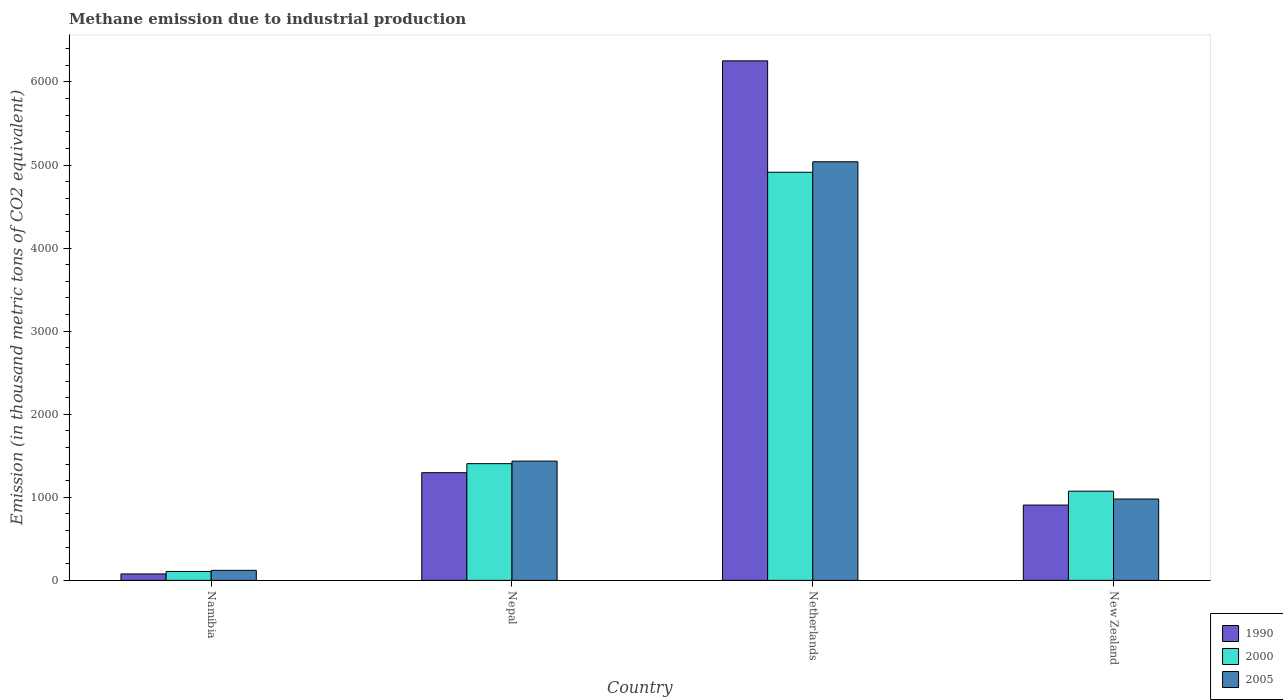How many different coloured bars are there?
Ensure brevity in your answer.  3. Are the number of bars per tick equal to the number of legend labels?
Make the answer very short. Yes. How many bars are there on the 1st tick from the left?
Your answer should be compact. 3. What is the label of the 1st group of bars from the left?
Offer a very short reply. Namibia. In how many cases, is the number of bars for a given country not equal to the number of legend labels?
Offer a very short reply. 0. What is the amount of methane emitted in 2000 in Namibia?
Give a very brief answer. 107.4. Across all countries, what is the maximum amount of methane emitted in 2000?
Offer a very short reply. 4913.4. Across all countries, what is the minimum amount of methane emitted in 2005?
Provide a short and direct response. 121. In which country was the amount of methane emitted in 2000 minimum?
Keep it short and to the point. Namibia. What is the total amount of methane emitted in 2000 in the graph?
Ensure brevity in your answer.  7499.9. What is the difference between the amount of methane emitted in 1990 in Namibia and that in Netherlands?
Provide a short and direct response. -6176.8. What is the difference between the amount of methane emitted in 2000 in New Zealand and the amount of methane emitted in 2005 in Netherlands?
Provide a short and direct response. -3965.5. What is the average amount of methane emitted in 2000 per country?
Your answer should be compact. 1874.97. What is the difference between the amount of methane emitted of/in 2000 and amount of methane emitted of/in 2005 in New Zealand?
Your response must be concise. 94.6. In how many countries, is the amount of methane emitted in 2005 greater than 6200 thousand metric tons?
Give a very brief answer. 0. What is the ratio of the amount of methane emitted in 2000 in Namibia to that in Nepal?
Your answer should be very brief. 0.08. Is the difference between the amount of methane emitted in 2000 in Namibia and Netherlands greater than the difference between the amount of methane emitted in 2005 in Namibia and Netherlands?
Provide a succinct answer. Yes. What is the difference between the highest and the second highest amount of methane emitted in 2005?
Provide a short and direct response. 456.4. What is the difference between the highest and the lowest amount of methane emitted in 2005?
Provide a succinct answer. 4918.5. In how many countries, is the amount of methane emitted in 1990 greater than the average amount of methane emitted in 1990 taken over all countries?
Your response must be concise. 1. Is the sum of the amount of methane emitted in 2005 in Nepal and Netherlands greater than the maximum amount of methane emitted in 1990 across all countries?
Your answer should be very brief. Yes. What does the 3rd bar from the left in New Zealand represents?
Offer a terse response. 2005. What does the 1st bar from the right in New Zealand represents?
Provide a succinct answer. 2005. Are all the bars in the graph horizontal?
Keep it short and to the point. No. How many countries are there in the graph?
Your answer should be compact. 4. Are the values on the major ticks of Y-axis written in scientific E-notation?
Offer a very short reply. No. Where does the legend appear in the graph?
Provide a short and direct response. Bottom right. How are the legend labels stacked?
Offer a terse response. Vertical. What is the title of the graph?
Make the answer very short. Methane emission due to industrial production. What is the label or title of the X-axis?
Your answer should be compact. Country. What is the label or title of the Y-axis?
Provide a short and direct response. Emission (in thousand metric tons of CO2 equivalent). What is the Emission (in thousand metric tons of CO2 equivalent) in 1990 in Namibia?
Provide a succinct answer. 77.6. What is the Emission (in thousand metric tons of CO2 equivalent) of 2000 in Namibia?
Your answer should be compact. 107.4. What is the Emission (in thousand metric tons of CO2 equivalent) in 2005 in Namibia?
Your response must be concise. 121. What is the Emission (in thousand metric tons of CO2 equivalent) in 1990 in Nepal?
Provide a succinct answer. 1296.6. What is the Emission (in thousand metric tons of CO2 equivalent) in 2000 in Nepal?
Ensure brevity in your answer.  1405.1. What is the Emission (in thousand metric tons of CO2 equivalent) in 2005 in Nepal?
Offer a terse response. 1435.8. What is the Emission (in thousand metric tons of CO2 equivalent) in 1990 in Netherlands?
Offer a very short reply. 6254.4. What is the Emission (in thousand metric tons of CO2 equivalent) in 2000 in Netherlands?
Make the answer very short. 4913.4. What is the Emission (in thousand metric tons of CO2 equivalent) in 2005 in Netherlands?
Provide a short and direct response. 5039.5. What is the Emission (in thousand metric tons of CO2 equivalent) in 1990 in New Zealand?
Your answer should be very brief. 906.8. What is the Emission (in thousand metric tons of CO2 equivalent) in 2000 in New Zealand?
Keep it short and to the point. 1074. What is the Emission (in thousand metric tons of CO2 equivalent) of 2005 in New Zealand?
Ensure brevity in your answer.  979.4. Across all countries, what is the maximum Emission (in thousand metric tons of CO2 equivalent) in 1990?
Keep it short and to the point. 6254.4. Across all countries, what is the maximum Emission (in thousand metric tons of CO2 equivalent) in 2000?
Your answer should be very brief. 4913.4. Across all countries, what is the maximum Emission (in thousand metric tons of CO2 equivalent) in 2005?
Provide a succinct answer. 5039.5. Across all countries, what is the minimum Emission (in thousand metric tons of CO2 equivalent) of 1990?
Your answer should be compact. 77.6. Across all countries, what is the minimum Emission (in thousand metric tons of CO2 equivalent) of 2000?
Offer a very short reply. 107.4. Across all countries, what is the minimum Emission (in thousand metric tons of CO2 equivalent) in 2005?
Ensure brevity in your answer.  121. What is the total Emission (in thousand metric tons of CO2 equivalent) of 1990 in the graph?
Your answer should be very brief. 8535.4. What is the total Emission (in thousand metric tons of CO2 equivalent) of 2000 in the graph?
Your answer should be very brief. 7499.9. What is the total Emission (in thousand metric tons of CO2 equivalent) in 2005 in the graph?
Give a very brief answer. 7575.7. What is the difference between the Emission (in thousand metric tons of CO2 equivalent) of 1990 in Namibia and that in Nepal?
Provide a succinct answer. -1219. What is the difference between the Emission (in thousand metric tons of CO2 equivalent) in 2000 in Namibia and that in Nepal?
Your answer should be very brief. -1297.7. What is the difference between the Emission (in thousand metric tons of CO2 equivalent) of 2005 in Namibia and that in Nepal?
Your answer should be compact. -1314.8. What is the difference between the Emission (in thousand metric tons of CO2 equivalent) in 1990 in Namibia and that in Netherlands?
Your answer should be very brief. -6176.8. What is the difference between the Emission (in thousand metric tons of CO2 equivalent) of 2000 in Namibia and that in Netherlands?
Your response must be concise. -4806. What is the difference between the Emission (in thousand metric tons of CO2 equivalent) in 2005 in Namibia and that in Netherlands?
Your answer should be very brief. -4918.5. What is the difference between the Emission (in thousand metric tons of CO2 equivalent) in 1990 in Namibia and that in New Zealand?
Offer a very short reply. -829.2. What is the difference between the Emission (in thousand metric tons of CO2 equivalent) of 2000 in Namibia and that in New Zealand?
Offer a terse response. -966.6. What is the difference between the Emission (in thousand metric tons of CO2 equivalent) of 2005 in Namibia and that in New Zealand?
Offer a terse response. -858.4. What is the difference between the Emission (in thousand metric tons of CO2 equivalent) of 1990 in Nepal and that in Netherlands?
Provide a succinct answer. -4957.8. What is the difference between the Emission (in thousand metric tons of CO2 equivalent) of 2000 in Nepal and that in Netherlands?
Provide a short and direct response. -3508.3. What is the difference between the Emission (in thousand metric tons of CO2 equivalent) of 2005 in Nepal and that in Netherlands?
Offer a terse response. -3603.7. What is the difference between the Emission (in thousand metric tons of CO2 equivalent) of 1990 in Nepal and that in New Zealand?
Your answer should be very brief. 389.8. What is the difference between the Emission (in thousand metric tons of CO2 equivalent) in 2000 in Nepal and that in New Zealand?
Keep it short and to the point. 331.1. What is the difference between the Emission (in thousand metric tons of CO2 equivalent) of 2005 in Nepal and that in New Zealand?
Provide a short and direct response. 456.4. What is the difference between the Emission (in thousand metric tons of CO2 equivalent) of 1990 in Netherlands and that in New Zealand?
Your response must be concise. 5347.6. What is the difference between the Emission (in thousand metric tons of CO2 equivalent) of 2000 in Netherlands and that in New Zealand?
Offer a very short reply. 3839.4. What is the difference between the Emission (in thousand metric tons of CO2 equivalent) of 2005 in Netherlands and that in New Zealand?
Provide a succinct answer. 4060.1. What is the difference between the Emission (in thousand metric tons of CO2 equivalent) of 1990 in Namibia and the Emission (in thousand metric tons of CO2 equivalent) of 2000 in Nepal?
Offer a very short reply. -1327.5. What is the difference between the Emission (in thousand metric tons of CO2 equivalent) in 1990 in Namibia and the Emission (in thousand metric tons of CO2 equivalent) in 2005 in Nepal?
Offer a terse response. -1358.2. What is the difference between the Emission (in thousand metric tons of CO2 equivalent) in 2000 in Namibia and the Emission (in thousand metric tons of CO2 equivalent) in 2005 in Nepal?
Ensure brevity in your answer.  -1328.4. What is the difference between the Emission (in thousand metric tons of CO2 equivalent) in 1990 in Namibia and the Emission (in thousand metric tons of CO2 equivalent) in 2000 in Netherlands?
Offer a terse response. -4835.8. What is the difference between the Emission (in thousand metric tons of CO2 equivalent) in 1990 in Namibia and the Emission (in thousand metric tons of CO2 equivalent) in 2005 in Netherlands?
Provide a succinct answer. -4961.9. What is the difference between the Emission (in thousand metric tons of CO2 equivalent) in 2000 in Namibia and the Emission (in thousand metric tons of CO2 equivalent) in 2005 in Netherlands?
Your response must be concise. -4932.1. What is the difference between the Emission (in thousand metric tons of CO2 equivalent) of 1990 in Namibia and the Emission (in thousand metric tons of CO2 equivalent) of 2000 in New Zealand?
Make the answer very short. -996.4. What is the difference between the Emission (in thousand metric tons of CO2 equivalent) of 1990 in Namibia and the Emission (in thousand metric tons of CO2 equivalent) of 2005 in New Zealand?
Make the answer very short. -901.8. What is the difference between the Emission (in thousand metric tons of CO2 equivalent) of 2000 in Namibia and the Emission (in thousand metric tons of CO2 equivalent) of 2005 in New Zealand?
Provide a succinct answer. -872. What is the difference between the Emission (in thousand metric tons of CO2 equivalent) in 1990 in Nepal and the Emission (in thousand metric tons of CO2 equivalent) in 2000 in Netherlands?
Make the answer very short. -3616.8. What is the difference between the Emission (in thousand metric tons of CO2 equivalent) in 1990 in Nepal and the Emission (in thousand metric tons of CO2 equivalent) in 2005 in Netherlands?
Offer a terse response. -3742.9. What is the difference between the Emission (in thousand metric tons of CO2 equivalent) in 2000 in Nepal and the Emission (in thousand metric tons of CO2 equivalent) in 2005 in Netherlands?
Offer a very short reply. -3634.4. What is the difference between the Emission (in thousand metric tons of CO2 equivalent) in 1990 in Nepal and the Emission (in thousand metric tons of CO2 equivalent) in 2000 in New Zealand?
Provide a succinct answer. 222.6. What is the difference between the Emission (in thousand metric tons of CO2 equivalent) of 1990 in Nepal and the Emission (in thousand metric tons of CO2 equivalent) of 2005 in New Zealand?
Give a very brief answer. 317.2. What is the difference between the Emission (in thousand metric tons of CO2 equivalent) of 2000 in Nepal and the Emission (in thousand metric tons of CO2 equivalent) of 2005 in New Zealand?
Give a very brief answer. 425.7. What is the difference between the Emission (in thousand metric tons of CO2 equivalent) of 1990 in Netherlands and the Emission (in thousand metric tons of CO2 equivalent) of 2000 in New Zealand?
Your answer should be very brief. 5180.4. What is the difference between the Emission (in thousand metric tons of CO2 equivalent) in 1990 in Netherlands and the Emission (in thousand metric tons of CO2 equivalent) in 2005 in New Zealand?
Give a very brief answer. 5275. What is the difference between the Emission (in thousand metric tons of CO2 equivalent) of 2000 in Netherlands and the Emission (in thousand metric tons of CO2 equivalent) of 2005 in New Zealand?
Provide a succinct answer. 3934. What is the average Emission (in thousand metric tons of CO2 equivalent) in 1990 per country?
Provide a succinct answer. 2133.85. What is the average Emission (in thousand metric tons of CO2 equivalent) in 2000 per country?
Offer a terse response. 1874.97. What is the average Emission (in thousand metric tons of CO2 equivalent) of 2005 per country?
Your response must be concise. 1893.92. What is the difference between the Emission (in thousand metric tons of CO2 equivalent) in 1990 and Emission (in thousand metric tons of CO2 equivalent) in 2000 in Namibia?
Give a very brief answer. -29.8. What is the difference between the Emission (in thousand metric tons of CO2 equivalent) in 1990 and Emission (in thousand metric tons of CO2 equivalent) in 2005 in Namibia?
Ensure brevity in your answer.  -43.4. What is the difference between the Emission (in thousand metric tons of CO2 equivalent) of 1990 and Emission (in thousand metric tons of CO2 equivalent) of 2000 in Nepal?
Give a very brief answer. -108.5. What is the difference between the Emission (in thousand metric tons of CO2 equivalent) of 1990 and Emission (in thousand metric tons of CO2 equivalent) of 2005 in Nepal?
Your answer should be very brief. -139.2. What is the difference between the Emission (in thousand metric tons of CO2 equivalent) in 2000 and Emission (in thousand metric tons of CO2 equivalent) in 2005 in Nepal?
Give a very brief answer. -30.7. What is the difference between the Emission (in thousand metric tons of CO2 equivalent) in 1990 and Emission (in thousand metric tons of CO2 equivalent) in 2000 in Netherlands?
Make the answer very short. 1341. What is the difference between the Emission (in thousand metric tons of CO2 equivalent) in 1990 and Emission (in thousand metric tons of CO2 equivalent) in 2005 in Netherlands?
Ensure brevity in your answer.  1214.9. What is the difference between the Emission (in thousand metric tons of CO2 equivalent) in 2000 and Emission (in thousand metric tons of CO2 equivalent) in 2005 in Netherlands?
Keep it short and to the point. -126.1. What is the difference between the Emission (in thousand metric tons of CO2 equivalent) of 1990 and Emission (in thousand metric tons of CO2 equivalent) of 2000 in New Zealand?
Provide a short and direct response. -167.2. What is the difference between the Emission (in thousand metric tons of CO2 equivalent) in 1990 and Emission (in thousand metric tons of CO2 equivalent) in 2005 in New Zealand?
Keep it short and to the point. -72.6. What is the difference between the Emission (in thousand metric tons of CO2 equivalent) in 2000 and Emission (in thousand metric tons of CO2 equivalent) in 2005 in New Zealand?
Your answer should be very brief. 94.6. What is the ratio of the Emission (in thousand metric tons of CO2 equivalent) in 1990 in Namibia to that in Nepal?
Make the answer very short. 0.06. What is the ratio of the Emission (in thousand metric tons of CO2 equivalent) in 2000 in Namibia to that in Nepal?
Make the answer very short. 0.08. What is the ratio of the Emission (in thousand metric tons of CO2 equivalent) of 2005 in Namibia to that in Nepal?
Ensure brevity in your answer.  0.08. What is the ratio of the Emission (in thousand metric tons of CO2 equivalent) in 1990 in Namibia to that in Netherlands?
Your answer should be very brief. 0.01. What is the ratio of the Emission (in thousand metric tons of CO2 equivalent) of 2000 in Namibia to that in Netherlands?
Your answer should be compact. 0.02. What is the ratio of the Emission (in thousand metric tons of CO2 equivalent) of 2005 in Namibia to that in Netherlands?
Make the answer very short. 0.02. What is the ratio of the Emission (in thousand metric tons of CO2 equivalent) of 1990 in Namibia to that in New Zealand?
Make the answer very short. 0.09. What is the ratio of the Emission (in thousand metric tons of CO2 equivalent) of 2005 in Namibia to that in New Zealand?
Your answer should be compact. 0.12. What is the ratio of the Emission (in thousand metric tons of CO2 equivalent) in 1990 in Nepal to that in Netherlands?
Your answer should be very brief. 0.21. What is the ratio of the Emission (in thousand metric tons of CO2 equivalent) of 2000 in Nepal to that in Netherlands?
Your answer should be compact. 0.29. What is the ratio of the Emission (in thousand metric tons of CO2 equivalent) in 2005 in Nepal to that in Netherlands?
Make the answer very short. 0.28. What is the ratio of the Emission (in thousand metric tons of CO2 equivalent) in 1990 in Nepal to that in New Zealand?
Give a very brief answer. 1.43. What is the ratio of the Emission (in thousand metric tons of CO2 equivalent) in 2000 in Nepal to that in New Zealand?
Offer a terse response. 1.31. What is the ratio of the Emission (in thousand metric tons of CO2 equivalent) in 2005 in Nepal to that in New Zealand?
Ensure brevity in your answer.  1.47. What is the ratio of the Emission (in thousand metric tons of CO2 equivalent) in 1990 in Netherlands to that in New Zealand?
Keep it short and to the point. 6.9. What is the ratio of the Emission (in thousand metric tons of CO2 equivalent) in 2000 in Netherlands to that in New Zealand?
Offer a very short reply. 4.57. What is the ratio of the Emission (in thousand metric tons of CO2 equivalent) of 2005 in Netherlands to that in New Zealand?
Give a very brief answer. 5.15. What is the difference between the highest and the second highest Emission (in thousand metric tons of CO2 equivalent) of 1990?
Make the answer very short. 4957.8. What is the difference between the highest and the second highest Emission (in thousand metric tons of CO2 equivalent) in 2000?
Offer a terse response. 3508.3. What is the difference between the highest and the second highest Emission (in thousand metric tons of CO2 equivalent) in 2005?
Your response must be concise. 3603.7. What is the difference between the highest and the lowest Emission (in thousand metric tons of CO2 equivalent) in 1990?
Provide a succinct answer. 6176.8. What is the difference between the highest and the lowest Emission (in thousand metric tons of CO2 equivalent) of 2000?
Offer a terse response. 4806. What is the difference between the highest and the lowest Emission (in thousand metric tons of CO2 equivalent) of 2005?
Give a very brief answer. 4918.5. 